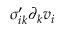Convert formula to latex. <formula><loc_0><loc_0><loc_500><loc_500>\sigma _ { i k } ^ { \prime } \partial _ { k } v _ { i }</formula> 